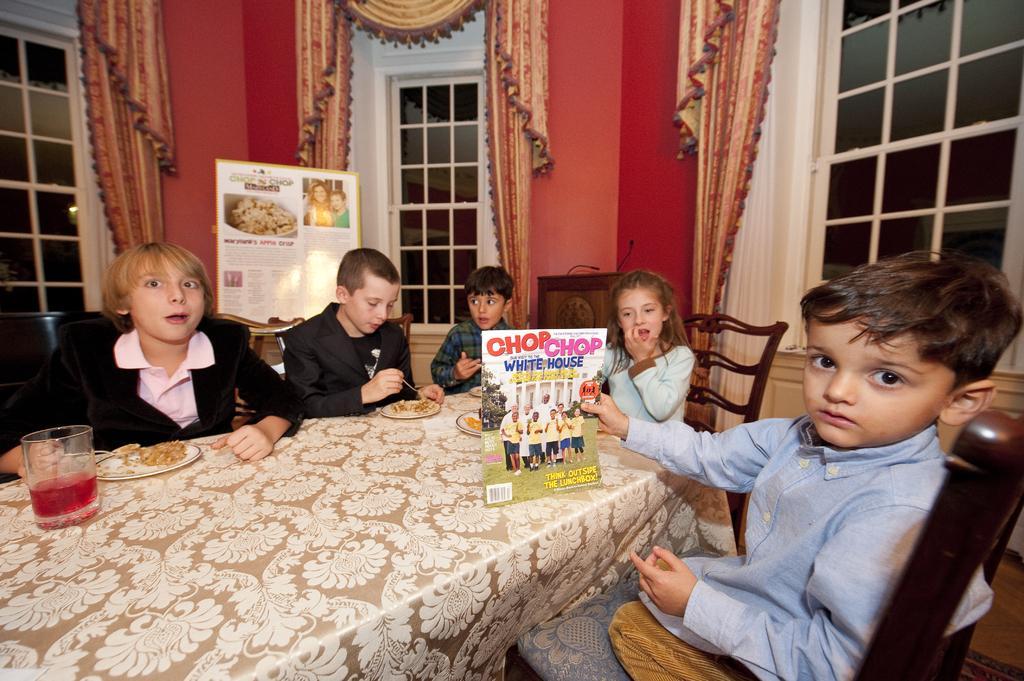In one or two sentences, can you explain what this image depicts? There are five members are sitting on a chair. There is a table. There is a glass,plate,spoon on a table. On the right side we have a boy. He's holding a book. We can see the background there is a curtain and window. 